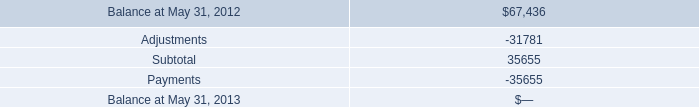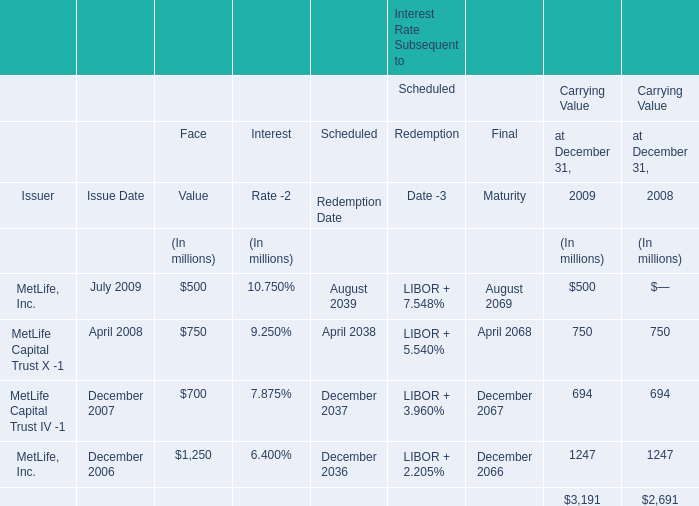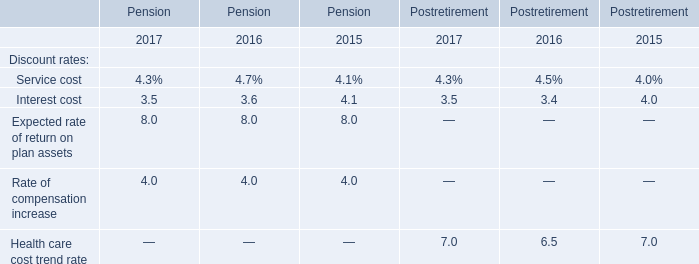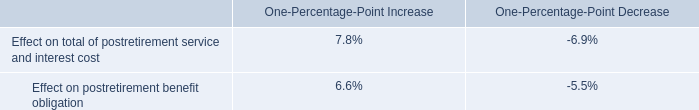What is the difference between 2009 and 2008 's highest Carrying Value (in million) 
Computations: (1247 - 1247)
Answer: 0.0. 